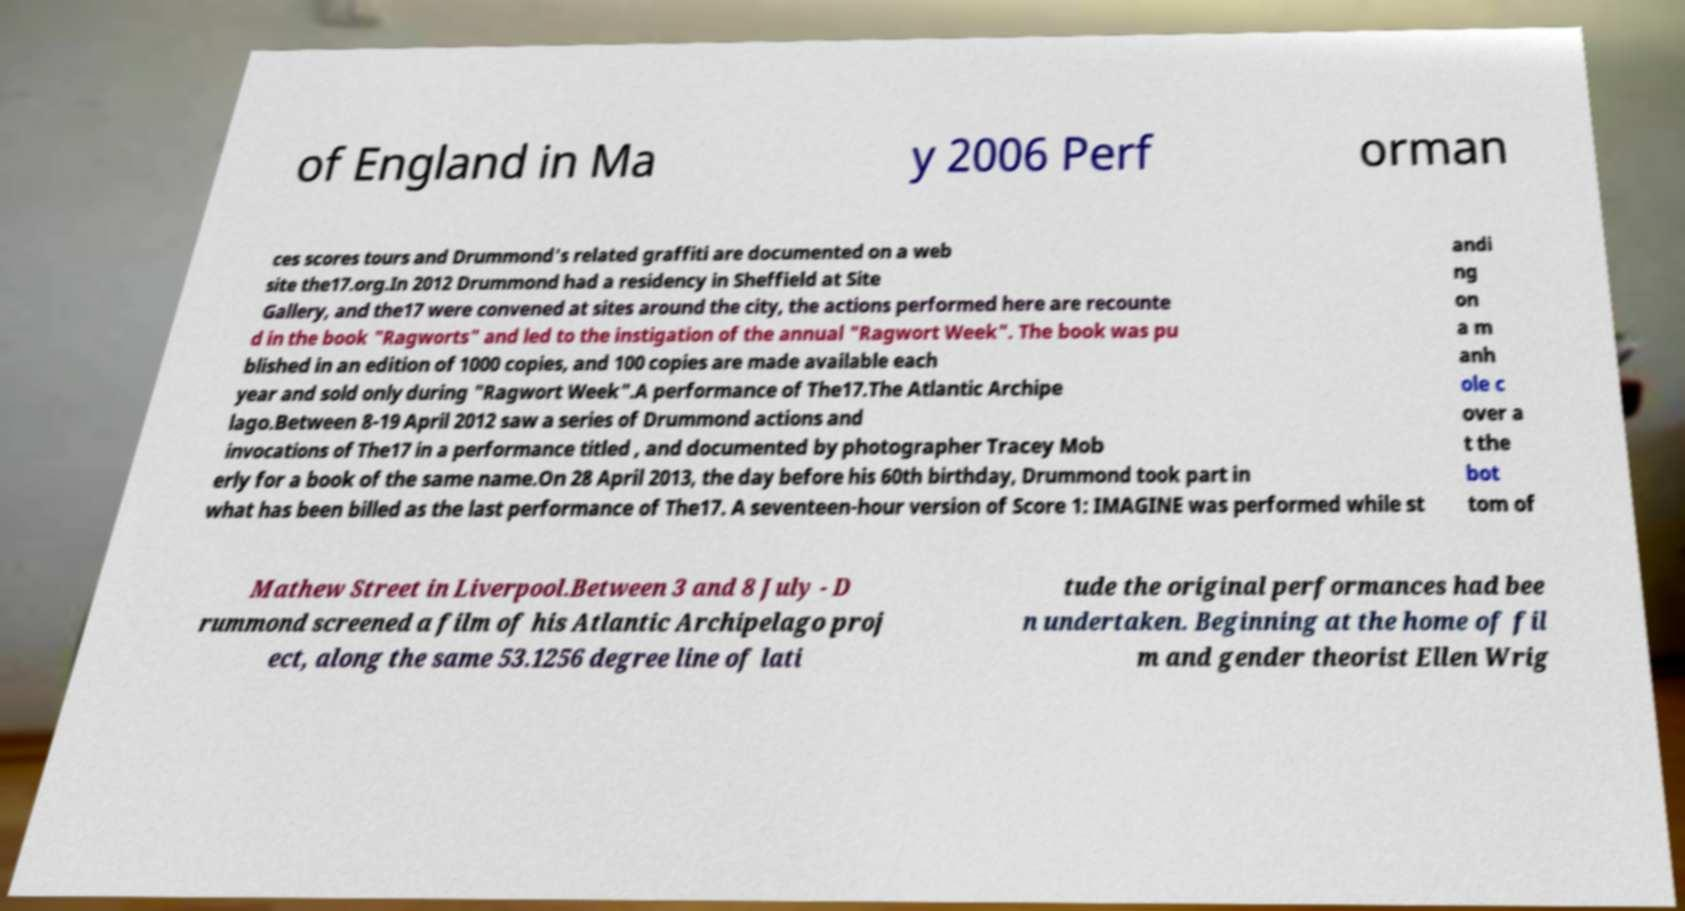For documentation purposes, I need the text within this image transcribed. Could you provide that? of England in Ma y 2006 Perf orman ces scores tours and Drummond's related graffiti are documented on a web site the17.org.In 2012 Drummond had a residency in Sheffield at Site Gallery, and the17 were convened at sites around the city, the actions performed here are recounte d in the book "Ragworts" and led to the instigation of the annual "Ragwort Week". The book was pu blished in an edition of 1000 copies, and 100 copies are made available each year and sold only during "Ragwort Week".A performance of The17.The Atlantic Archipe lago.Between 8-19 April 2012 saw a series of Drummond actions and invocations of The17 in a performance titled , and documented by photographer Tracey Mob erly for a book of the same name.On 28 April 2013, the day before his 60th birthday, Drummond took part in what has been billed as the last performance of The17. A seventeen-hour version of Score 1: IMAGINE was performed while st andi ng on a m anh ole c over a t the bot tom of Mathew Street in Liverpool.Between 3 and 8 July - D rummond screened a film of his Atlantic Archipelago proj ect, along the same 53.1256 degree line of lati tude the original performances had bee n undertaken. Beginning at the home of fil m and gender theorist Ellen Wrig 